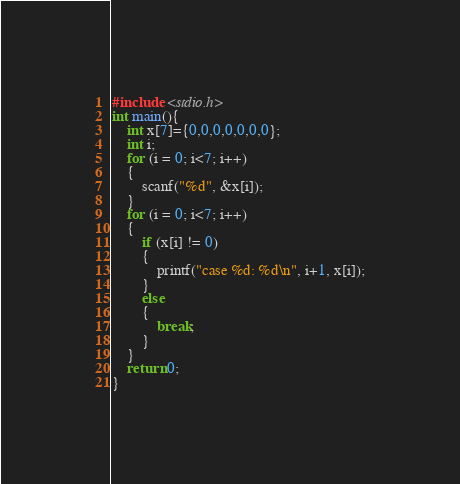Convert code to text. <code><loc_0><loc_0><loc_500><loc_500><_C_>#include <stdio.h>
int main(){
	int x[7]={0,0,0,0,0,0,0};
	int i;
	for (i = 0; i<7; i++)
	{
	    scanf("%d", &x[i]);
	}
	for (i = 0; i<7; i++)
	{
		if (x[i] != 0)
		{
		    printf("case %d: %d\n", i+1, x[i]);
		}
		else
		{
			break;
		}
	}
	return 0;
}</code> 